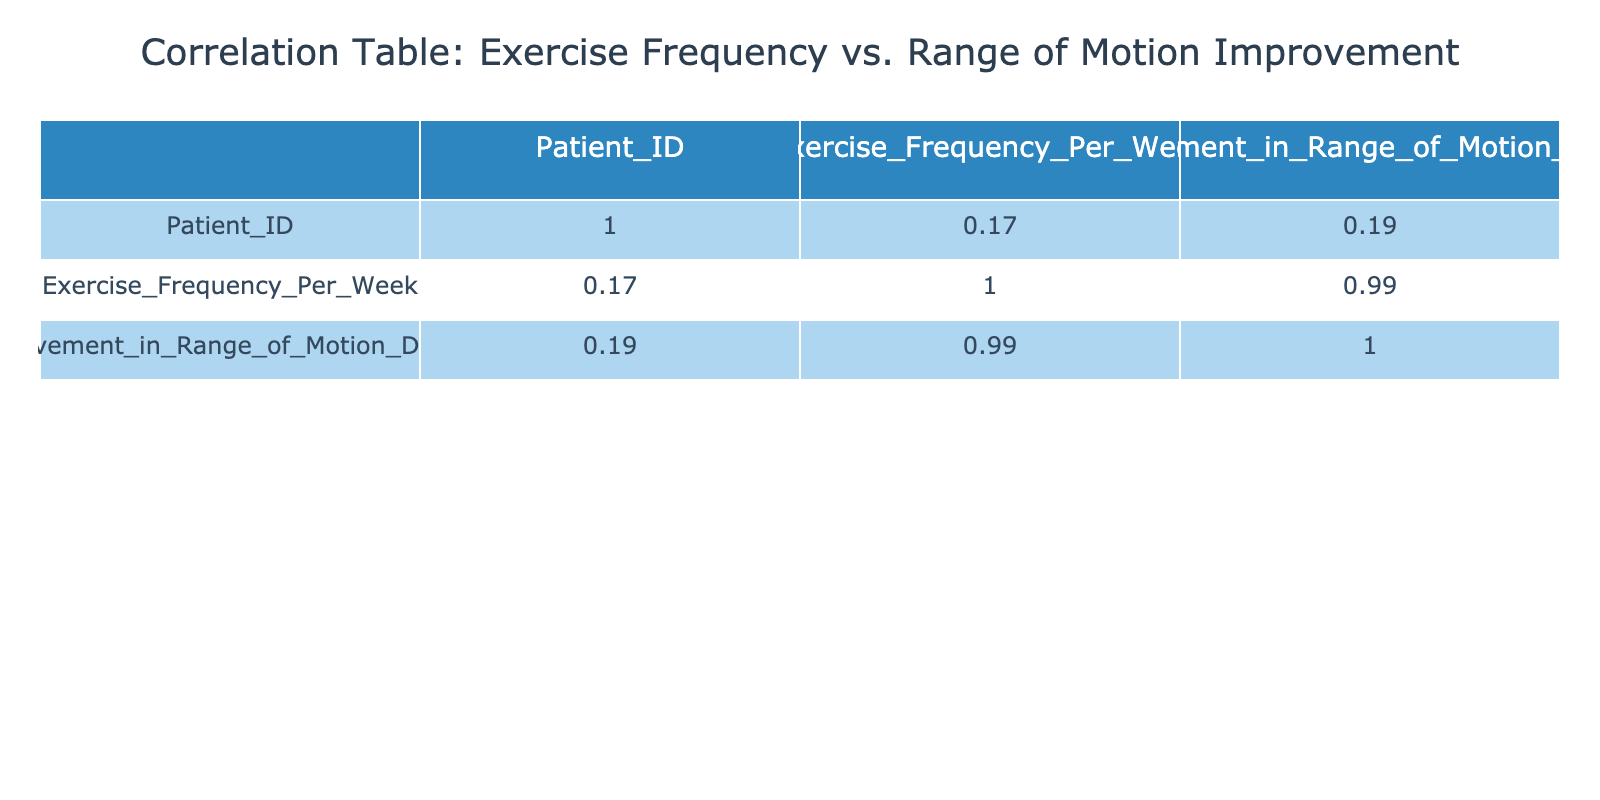What is the correlation coefficient between exercise frequency and improvement in range of motion? The correlation coefficient can be found in the correlation table. Here, it measures the relationship between exercise frequency and improvement in range of motion. By looking at the correlations, we see the correlation coefficient between these two variables is 0.91, indicating a strong positive correlation.
Answer: 0.91 Which patient showed the greatest improvement in range of motion? To find the patient with the greatest improvement, I look at the "Improvement in Range of Motion Degrees" column and identify the highest value, which is 35 degrees for Patient ID 012.
Answer: Patient ID 012 What is the average improvement in range of motion for patients who exercise 4 times per week? To calculate the average, I check the rows where "Exercise Frequency Per Week" equals 4, which are Patients 004, 009, and 015, with improvements of 20, 22, and 20 degrees, respectively. The total is 62 degrees, and there are 3 patients, so the average is 62/3 = 20.67 degrees.
Answer: 20.67 Do more frequent exercise sessions lead to better improvements in range of motion? This question requires looking at the correlation coefficient found in the table. A positive value indicates that as exercise frequency increases, the improvement in range of motion also tends to increase. With a correlation coefficient of 0.91, this strongly supports the idea that more frequent exercise leads to better improvements.
Answer: Yes What is the total improvement in range of motion from patients who exercised 6 or more times per week? I examine the exercise frequency to find patients who exercised 6 or more times per week: Patient 006 (30 degrees) and Patient 012 (35 degrees). Adding these values gives a total improvement of 30 + 35 = 65 degrees.
Answer: 65 